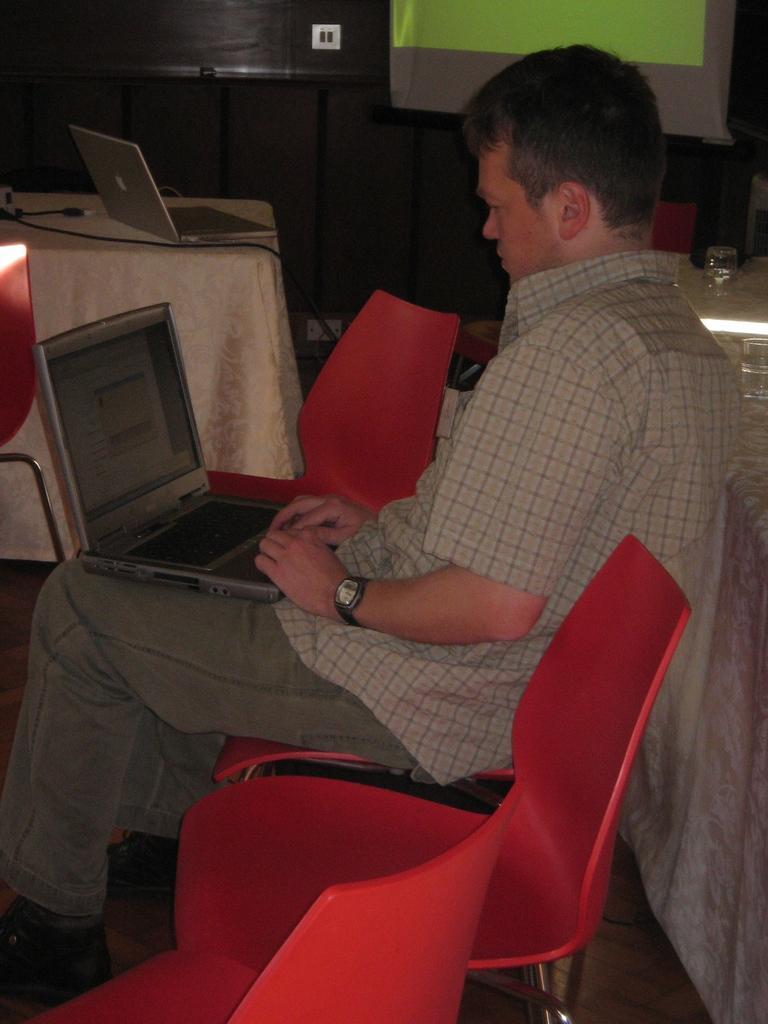In one or two sentences, can you explain what this image depicts? Here we can see a man sitting on chairs present in the room and he is operating a laptop and there are tables present here and there and we can see laptop present on the table 